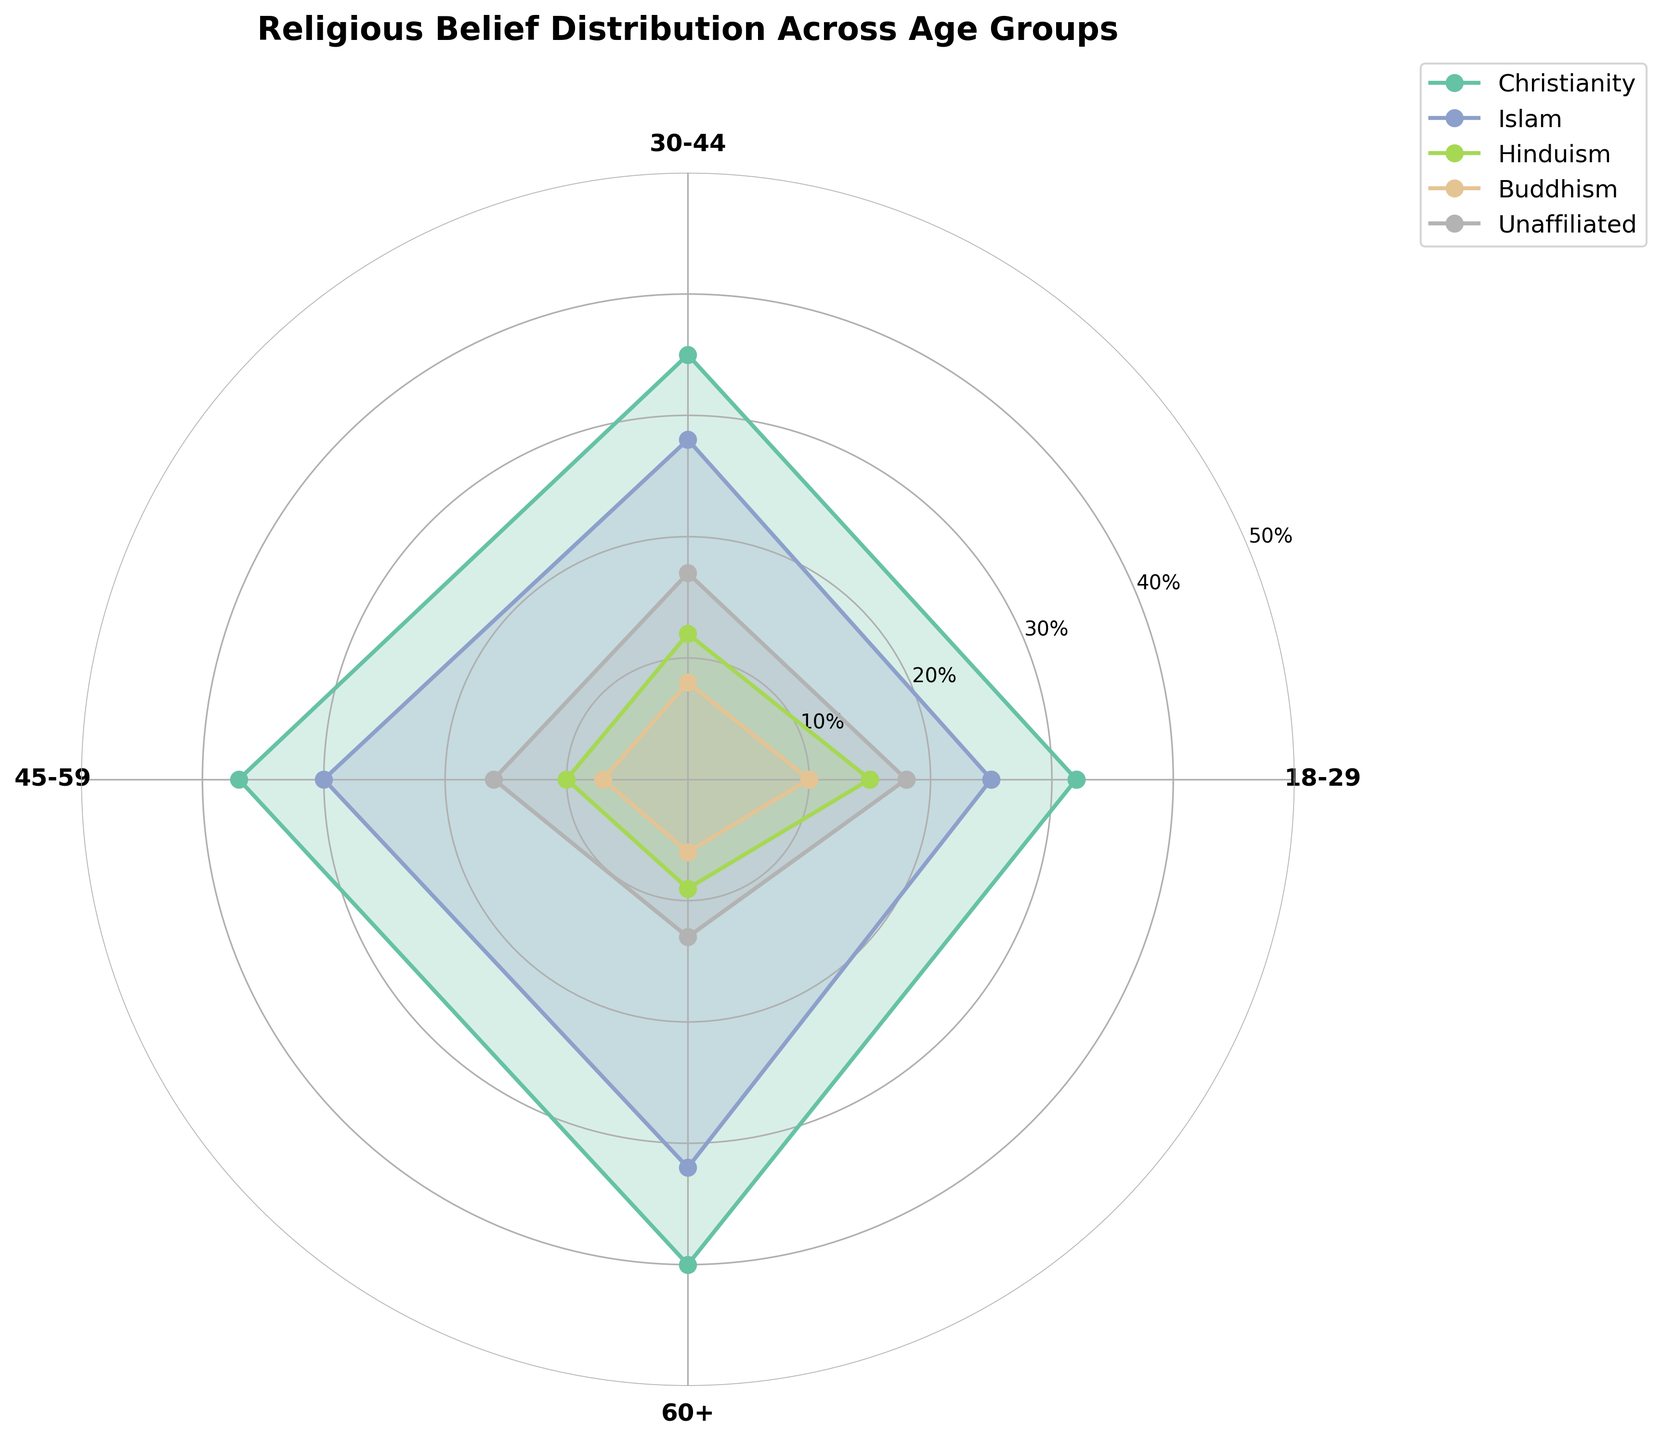What is the title of the plot? The title of the plot is located at the top and is typically formatted in a larger and bolder font compared to other text elements in the figure. In this case, it is "Religious Belief Distribution Across Age Groups".
Answer: Religious Belief Distribution Across Age Groups Which age group has the highest percentage of Christians? To determine the age group with the highest Christian percentage, check the data points within the "Christianity" line. The highest value corresponds to the 60+ age group.
Answer: 60+ What is the difference in the percentage of unaffiliated people between the age groups 18-29 and 60+? To find the difference, subtract the percentage of unaffiliated people in the 60+ age group from the 18-29 age group. This gives 18% - 13% = 5%.
Answer: 5% Between which two consecutive age groups does the percentage of Muslims show the largest increase? To find the largest increase, examine the Muslim percentage values across age groups: 18-29 (25%), 30-44 (28%), 45-59 (30%), and 60+ (32%). The largest increase is from 18-29 to 30-44 with a value increase from 25% to 28%.
Answer: 18-29 to 30-44 Which religion shows the least variation in percentage across age groups? Examine the variations in percentages for each religion. Buddhism has values of 10%, 8%, 7%, and 6% across different age groups, showing the least variation compared to others.
Answer: Buddhism How does the distribution of Hinduism change as age increases? Starting from the 18-29 group, the Hinduism percentage decreases steadily: 18-29 (15%), 30-44 (12%), 45-59 (10%), 60+ (9%). This describes a gradual decline.
Answer: Gradual decline What is the average percentage of Buddhists across all age groups? To find the average, sum the percentages of Buddhists across all age groups and divide by the number of age groups: (10% + 8% + 7% + 6%) / 4 = 7.75%.
Answer: 7.75% Which religion dominates the 30-44 age group, and by what margin compared to the second most prevalent religion? In the 30-44 age group, Christianity has the highest percentage (35%), followed by Islam (28%). The margin is 35% - 28% = 7%.
Answer: Christianity, 7% margin How do the percentage trends of Islam compare to Christianity across the age groups? Both Islam and Christianity show an increasing trend with age. Christianity starts at 32%, increasing to 40%, while Islam starts at 25% and increases to 32%. Christianity consistently has higher percentages than Islam across all age groups.
Answer: Both increase; Christianity always higher 